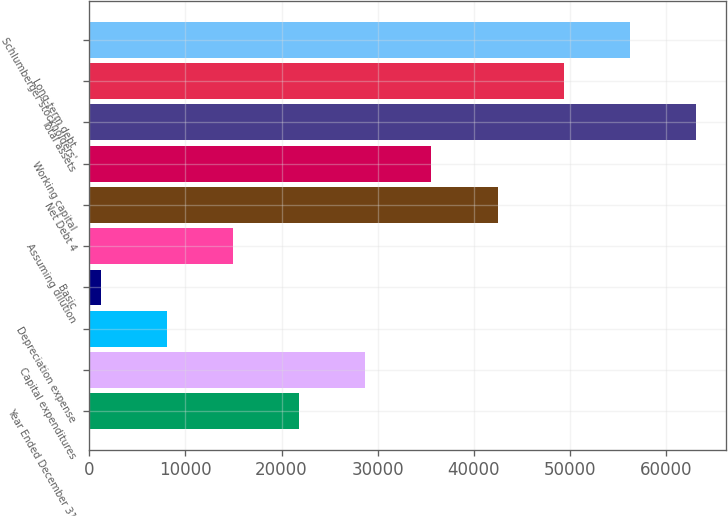Convert chart. <chart><loc_0><loc_0><loc_500><loc_500><bar_chart><fcel>Year Ended December 31<fcel>Capital expenditures<fcel>Depreciation expense<fcel>Basic<fcel>Assuming dilution<fcel>Net Debt 4<fcel>Working capital<fcel>Total assets<fcel>Long-term debt<fcel>Schlumberger stockholders'<nl><fcel>21827.4<fcel>28709.2<fcel>8063.8<fcel>1182<fcel>14945.6<fcel>42472.8<fcel>35591<fcel>63118.2<fcel>49354.6<fcel>56236.4<nl></chart> 